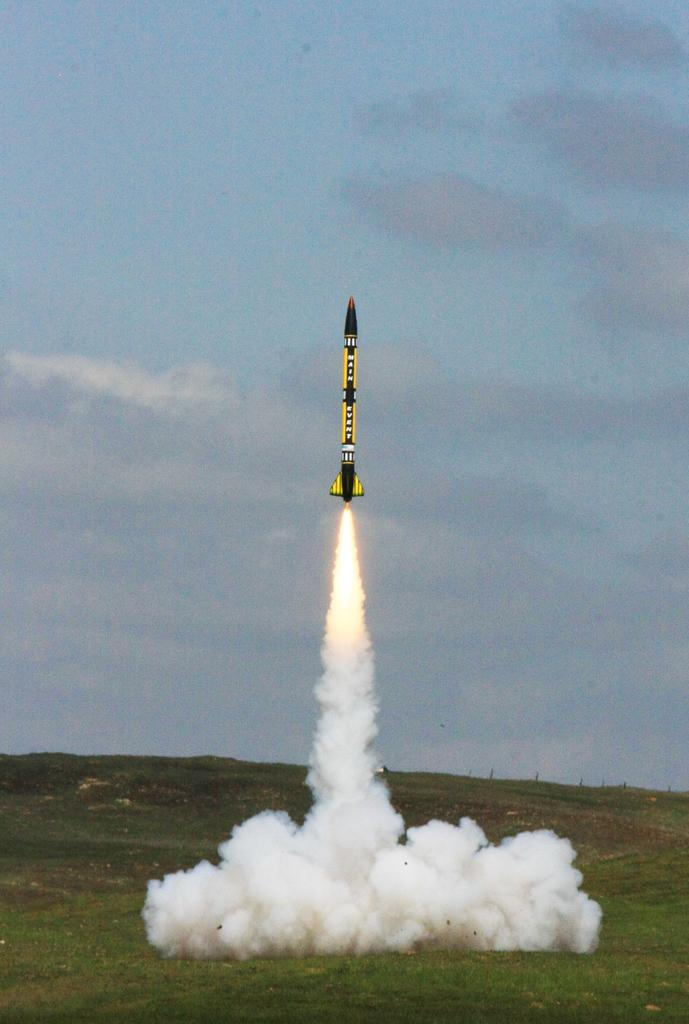What is the main subject in the center of the image? There is a rocket in the center of the image. What type of terrain is visible at the bottom of the image? There is grass at the bottom of the image. What can be seen in the background of the image? The sky is visible in the background of the image. How many factories can be seen in the image? There is no mention of factories in the image; it features a rocket, grass, and the sky. 